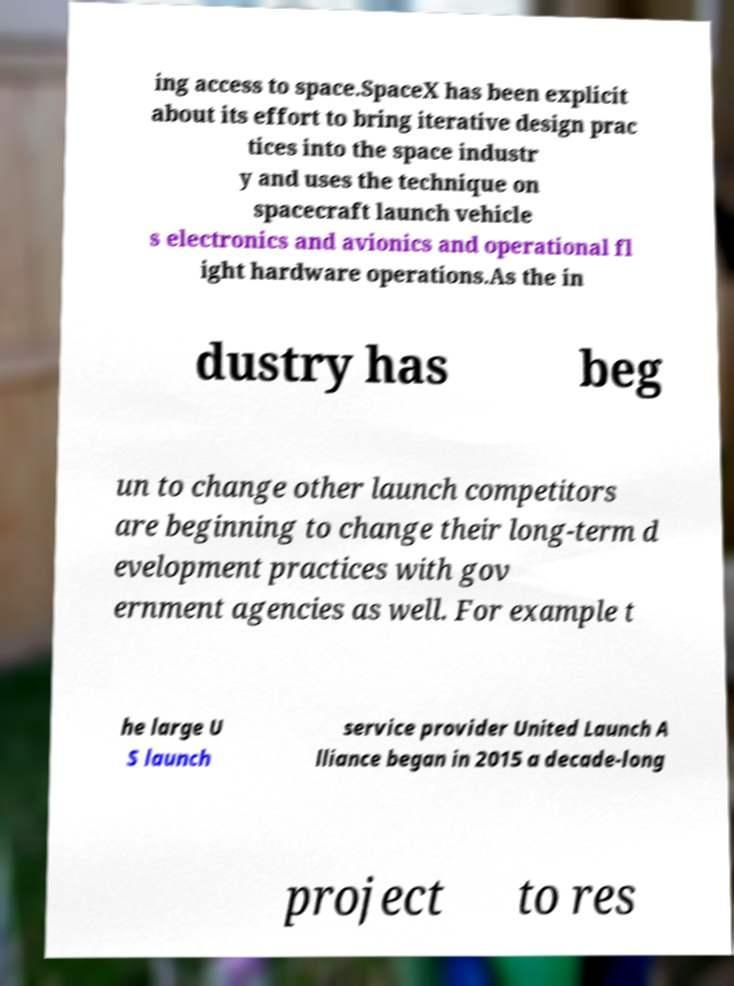For documentation purposes, I need the text within this image transcribed. Could you provide that? ing access to space.SpaceX has been explicit about its effort to bring iterative design prac tices into the space industr y and uses the technique on spacecraft launch vehicle s electronics and avionics and operational fl ight hardware operations.As the in dustry has beg un to change other launch competitors are beginning to change their long-term d evelopment practices with gov ernment agencies as well. For example t he large U S launch service provider United Launch A lliance began in 2015 a decade-long project to res 